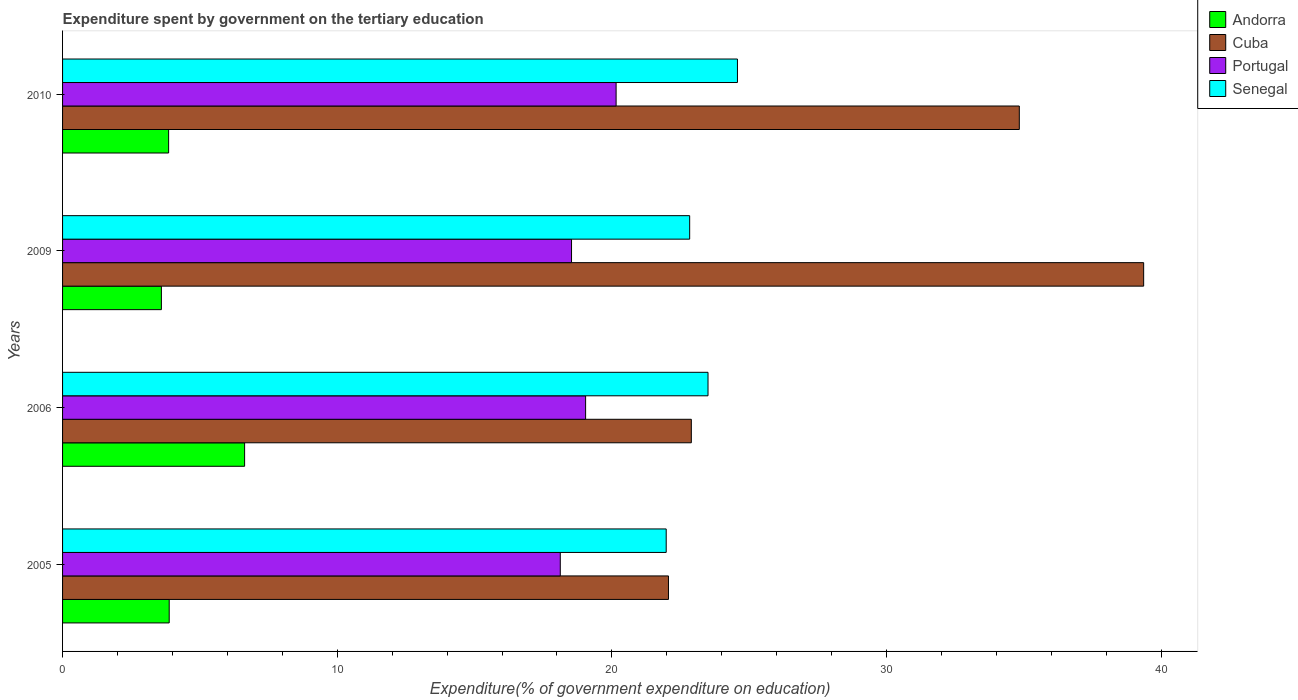Are the number of bars per tick equal to the number of legend labels?
Your answer should be very brief. Yes. How many bars are there on the 2nd tick from the top?
Your answer should be compact. 4. What is the label of the 1st group of bars from the top?
Provide a short and direct response. 2010. In how many cases, is the number of bars for a given year not equal to the number of legend labels?
Your answer should be very brief. 0. What is the expenditure spent by government on the tertiary education in Cuba in 2010?
Offer a terse response. 34.83. Across all years, what is the maximum expenditure spent by government on the tertiary education in Senegal?
Your answer should be very brief. 24.57. Across all years, what is the minimum expenditure spent by government on the tertiary education in Senegal?
Your response must be concise. 21.98. In which year was the expenditure spent by government on the tertiary education in Senegal minimum?
Offer a terse response. 2005. What is the total expenditure spent by government on the tertiary education in Andorra in the graph?
Make the answer very short. 17.97. What is the difference between the expenditure spent by government on the tertiary education in Senegal in 2005 and that in 2006?
Provide a succinct answer. -1.52. What is the difference between the expenditure spent by government on the tertiary education in Portugal in 2010 and the expenditure spent by government on the tertiary education in Cuba in 2009?
Your answer should be compact. -19.21. What is the average expenditure spent by government on the tertiary education in Andorra per year?
Your response must be concise. 4.49. In the year 2009, what is the difference between the expenditure spent by government on the tertiary education in Portugal and expenditure spent by government on the tertiary education in Senegal?
Offer a very short reply. -4.3. In how many years, is the expenditure spent by government on the tertiary education in Senegal greater than 8 %?
Your answer should be compact. 4. What is the ratio of the expenditure spent by government on the tertiary education in Portugal in 2005 to that in 2010?
Provide a succinct answer. 0.9. Is the expenditure spent by government on the tertiary education in Senegal in 2005 less than that in 2006?
Make the answer very short. Yes. Is the difference between the expenditure spent by government on the tertiary education in Portugal in 2009 and 2010 greater than the difference between the expenditure spent by government on the tertiary education in Senegal in 2009 and 2010?
Ensure brevity in your answer.  Yes. What is the difference between the highest and the second highest expenditure spent by government on the tertiary education in Portugal?
Keep it short and to the point. 1.11. What is the difference between the highest and the lowest expenditure spent by government on the tertiary education in Cuba?
Your answer should be compact. 17.3. What does the 1st bar from the top in 2005 represents?
Give a very brief answer. Senegal. What does the 2nd bar from the bottom in 2006 represents?
Provide a short and direct response. Cuba. Is it the case that in every year, the sum of the expenditure spent by government on the tertiary education in Senegal and expenditure spent by government on the tertiary education in Cuba is greater than the expenditure spent by government on the tertiary education in Portugal?
Provide a short and direct response. Yes. How many bars are there?
Provide a succinct answer. 16. Are all the bars in the graph horizontal?
Offer a very short reply. Yes. How many years are there in the graph?
Keep it short and to the point. 4. Does the graph contain any zero values?
Your response must be concise. No. Does the graph contain grids?
Make the answer very short. No. How many legend labels are there?
Ensure brevity in your answer.  4. How are the legend labels stacked?
Offer a very short reply. Vertical. What is the title of the graph?
Your answer should be very brief. Expenditure spent by government on the tertiary education. What is the label or title of the X-axis?
Offer a very short reply. Expenditure(% of government expenditure on education). What is the Expenditure(% of government expenditure on education) in Andorra in 2005?
Ensure brevity in your answer.  3.88. What is the Expenditure(% of government expenditure on education) of Cuba in 2005?
Your answer should be compact. 22.06. What is the Expenditure(% of government expenditure on education) in Portugal in 2005?
Your response must be concise. 18.12. What is the Expenditure(% of government expenditure on education) of Senegal in 2005?
Your response must be concise. 21.98. What is the Expenditure(% of government expenditure on education) in Andorra in 2006?
Ensure brevity in your answer.  6.63. What is the Expenditure(% of government expenditure on education) in Cuba in 2006?
Your answer should be very brief. 22.89. What is the Expenditure(% of government expenditure on education) of Portugal in 2006?
Your answer should be very brief. 19.04. What is the Expenditure(% of government expenditure on education) in Senegal in 2006?
Give a very brief answer. 23.5. What is the Expenditure(% of government expenditure on education) in Andorra in 2009?
Ensure brevity in your answer.  3.6. What is the Expenditure(% of government expenditure on education) in Cuba in 2009?
Keep it short and to the point. 39.36. What is the Expenditure(% of government expenditure on education) in Portugal in 2009?
Provide a short and direct response. 18.53. What is the Expenditure(% of government expenditure on education) of Senegal in 2009?
Your answer should be compact. 22.83. What is the Expenditure(% of government expenditure on education) of Andorra in 2010?
Your response must be concise. 3.86. What is the Expenditure(% of government expenditure on education) of Cuba in 2010?
Make the answer very short. 34.83. What is the Expenditure(% of government expenditure on education) in Portugal in 2010?
Offer a terse response. 20.15. What is the Expenditure(% of government expenditure on education) in Senegal in 2010?
Offer a very short reply. 24.57. Across all years, what is the maximum Expenditure(% of government expenditure on education) of Andorra?
Provide a short and direct response. 6.63. Across all years, what is the maximum Expenditure(% of government expenditure on education) of Cuba?
Your response must be concise. 39.36. Across all years, what is the maximum Expenditure(% of government expenditure on education) of Portugal?
Provide a succinct answer. 20.15. Across all years, what is the maximum Expenditure(% of government expenditure on education) in Senegal?
Ensure brevity in your answer.  24.57. Across all years, what is the minimum Expenditure(% of government expenditure on education) in Andorra?
Your answer should be very brief. 3.6. Across all years, what is the minimum Expenditure(% of government expenditure on education) of Cuba?
Your answer should be very brief. 22.06. Across all years, what is the minimum Expenditure(% of government expenditure on education) of Portugal?
Your response must be concise. 18.12. Across all years, what is the minimum Expenditure(% of government expenditure on education) in Senegal?
Keep it short and to the point. 21.98. What is the total Expenditure(% of government expenditure on education) of Andorra in the graph?
Offer a very short reply. 17.97. What is the total Expenditure(% of government expenditure on education) of Cuba in the graph?
Offer a very short reply. 119.15. What is the total Expenditure(% of government expenditure on education) of Portugal in the graph?
Ensure brevity in your answer.  75.85. What is the total Expenditure(% of government expenditure on education) of Senegal in the graph?
Ensure brevity in your answer.  92.88. What is the difference between the Expenditure(% of government expenditure on education) in Andorra in 2005 and that in 2006?
Give a very brief answer. -2.75. What is the difference between the Expenditure(% of government expenditure on education) of Cuba in 2005 and that in 2006?
Provide a succinct answer. -0.83. What is the difference between the Expenditure(% of government expenditure on education) in Portugal in 2005 and that in 2006?
Offer a very short reply. -0.92. What is the difference between the Expenditure(% of government expenditure on education) in Senegal in 2005 and that in 2006?
Give a very brief answer. -1.52. What is the difference between the Expenditure(% of government expenditure on education) in Andorra in 2005 and that in 2009?
Make the answer very short. 0.28. What is the difference between the Expenditure(% of government expenditure on education) of Cuba in 2005 and that in 2009?
Make the answer very short. -17.3. What is the difference between the Expenditure(% of government expenditure on education) of Portugal in 2005 and that in 2009?
Your answer should be compact. -0.41. What is the difference between the Expenditure(% of government expenditure on education) of Senegal in 2005 and that in 2009?
Offer a terse response. -0.85. What is the difference between the Expenditure(% of government expenditure on education) of Andorra in 2005 and that in 2010?
Your response must be concise. 0.02. What is the difference between the Expenditure(% of government expenditure on education) of Cuba in 2005 and that in 2010?
Provide a short and direct response. -12.77. What is the difference between the Expenditure(% of government expenditure on education) in Portugal in 2005 and that in 2010?
Ensure brevity in your answer.  -2.03. What is the difference between the Expenditure(% of government expenditure on education) of Senegal in 2005 and that in 2010?
Your answer should be compact. -2.59. What is the difference between the Expenditure(% of government expenditure on education) in Andorra in 2006 and that in 2009?
Offer a very short reply. 3.03. What is the difference between the Expenditure(% of government expenditure on education) of Cuba in 2006 and that in 2009?
Your response must be concise. -16.47. What is the difference between the Expenditure(% of government expenditure on education) in Portugal in 2006 and that in 2009?
Offer a very short reply. 0.51. What is the difference between the Expenditure(% of government expenditure on education) in Senegal in 2006 and that in 2009?
Provide a succinct answer. 0.67. What is the difference between the Expenditure(% of government expenditure on education) of Andorra in 2006 and that in 2010?
Keep it short and to the point. 2.77. What is the difference between the Expenditure(% of government expenditure on education) in Cuba in 2006 and that in 2010?
Your answer should be compact. -11.94. What is the difference between the Expenditure(% of government expenditure on education) of Portugal in 2006 and that in 2010?
Offer a terse response. -1.11. What is the difference between the Expenditure(% of government expenditure on education) of Senegal in 2006 and that in 2010?
Provide a succinct answer. -1.07. What is the difference between the Expenditure(% of government expenditure on education) in Andorra in 2009 and that in 2010?
Keep it short and to the point. -0.26. What is the difference between the Expenditure(% of government expenditure on education) of Cuba in 2009 and that in 2010?
Offer a terse response. 4.53. What is the difference between the Expenditure(% of government expenditure on education) in Portugal in 2009 and that in 2010?
Keep it short and to the point. -1.62. What is the difference between the Expenditure(% of government expenditure on education) in Senegal in 2009 and that in 2010?
Provide a succinct answer. -1.74. What is the difference between the Expenditure(% of government expenditure on education) in Andorra in 2005 and the Expenditure(% of government expenditure on education) in Cuba in 2006?
Provide a short and direct response. -19.01. What is the difference between the Expenditure(% of government expenditure on education) of Andorra in 2005 and the Expenditure(% of government expenditure on education) of Portugal in 2006?
Your answer should be very brief. -15.16. What is the difference between the Expenditure(% of government expenditure on education) of Andorra in 2005 and the Expenditure(% of government expenditure on education) of Senegal in 2006?
Offer a very short reply. -19.62. What is the difference between the Expenditure(% of government expenditure on education) of Cuba in 2005 and the Expenditure(% of government expenditure on education) of Portugal in 2006?
Make the answer very short. 3.02. What is the difference between the Expenditure(% of government expenditure on education) of Cuba in 2005 and the Expenditure(% of government expenditure on education) of Senegal in 2006?
Make the answer very short. -1.44. What is the difference between the Expenditure(% of government expenditure on education) of Portugal in 2005 and the Expenditure(% of government expenditure on education) of Senegal in 2006?
Your answer should be very brief. -5.38. What is the difference between the Expenditure(% of government expenditure on education) of Andorra in 2005 and the Expenditure(% of government expenditure on education) of Cuba in 2009?
Offer a terse response. -35.48. What is the difference between the Expenditure(% of government expenditure on education) in Andorra in 2005 and the Expenditure(% of government expenditure on education) in Portugal in 2009?
Offer a very short reply. -14.65. What is the difference between the Expenditure(% of government expenditure on education) in Andorra in 2005 and the Expenditure(% of government expenditure on education) in Senegal in 2009?
Provide a succinct answer. -18.95. What is the difference between the Expenditure(% of government expenditure on education) of Cuba in 2005 and the Expenditure(% of government expenditure on education) of Portugal in 2009?
Your answer should be very brief. 3.53. What is the difference between the Expenditure(% of government expenditure on education) of Cuba in 2005 and the Expenditure(% of government expenditure on education) of Senegal in 2009?
Ensure brevity in your answer.  -0.77. What is the difference between the Expenditure(% of government expenditure on education) in Portugal in 2005 and the Expenditure(% of government expenditure on education) in Senegal in 2009?
Provide a succinct answer. -4.71. What is the difference between the Expenditure(% of government expenditure on education) of Andorra in 2005 and the Expenditure(% of government expenditure on education) of Cuba in 2010?
Your answer should be very brief. -30.95. What is the difference between the Expenditure(% of government expenditure on education) of Andorra in 2005 and the Expenditure(% of government expenditure on education) of Portugal in 2010?
Provide a succinct answer. -16.27. What is the difference between the Expenditure(% of government expenditure on education) of Andorra in 2005 and the Expenditure(% of government expenditure on education) of Senegal in 2010?
Your answer should be compact. -20.69. What is the difference between the Expenditure(% of government expenditure on education) of Cuba in 2005 and the Expenditure(% of government expenditure on education) of Portugal in 2010?
Keep it short and to the point. 1.91. What is the difference between the Expenditure(% of government expenditure on education) in Cuba in 2005 and the Expenditure(% of government expenditure on education) in Senegal in 2010?
Provide a short and direct response. -2.51. What is the difference between the Expenditure(% of government expenditure on education) of Portugal in 2005 and the Expenditure(% of government expenditure on education) of Senegal in 2010?
Give a very brief answer. -6.45. What is the difference between the Expenditure(% of government expenditure on education) of Andorra in 2006 and the Expenditure(% of government expenditure on education) of Cuba in 2009?
Your answer should be very brief. -32.73. What is the difference between the Expenditure(% of government expenditure on education) of Andorra in 2006 and the Expenditure(% of government expenditure on education) of Portugal in 2009?
Provide a short and direct response. -11.9. What is the difference between the Expenditure(% of government expenditure on education) in Andorra in 2006 and the Expenditure(% of government expenditure on education) in Senegal in 2009?
Provide a short and direct response. -16.2. What is the difference between the Expenditure(% of government expenditure on education) in Cuba in 2006 and the Expenditure(% of government expenditure on education) in Portugal in 2009?
Your response must be concise. 4.36. What is the difference between the Expenditure(% of government expenditure on education) in Cuba in 2006 and the Expenditure(% of government expenditure on education) in Senegal in 2009?
Your answer should be very brief. 0.06. What is the difference between the Expenditure(% of government expenditure on education) of Portugal in 2006 and the Expenditure(% of government expenditure on education) of Senegal in 2009?
Your response must be concise. -3.79. What is the difference between the Expenditure(% of government expenditure on education) in Andorra in 2006 and the Expenditure(% of government expenditure on education) in Cuba in 2010?
Make the answer very short. -28.21. What is the difference between the Expenditure(% of government expenditure on education) of Andorra in 2006 and the Expenditure(% of government expenditure on education) of Portugal in 2010?
Make the answer very short. -13.53. What is the difference between the Expenditure(% of government expenditure on education) in Andorra in 2006 and the Expenditure(% of government expenditure on education) in Senegal in 2010?
Keep it short and to the point. -17.94. What is the difference between the Expenditure(% of government expenditure on education) of Cuba in 2006 and the Expenditure(% of government expenditure on education) of Portugal in 2010?
Provide a succinct answer. 2.74. What is the difference between the Expenditure(% of government expenditure on education) in Cuba in 2006 and the Expenditure(% of government expenditure on education) in Senegal in 2010?
Provide a short and direct response. -1.68. What is the difference between the Expenditure(% of government expenditure on education) in Portugal in 2006 and the Expenditure(% of government expenditure on education) in Senegal in 2010?
Keep it short and to the point. -5.53. What is the difference between the Expenditure(% of government expenditure on education) of Andorra in 2009 and the Expenditure(% of government expenditure on education) of Cuba in 2010?
Offer a very short reply. -31.24. What is the difference between the Expenditure(% of government expenditure on education) in Andorra in 2009 and the Expenditure(% of government expenditure on education) in Portugal in 2010?
Give a very brief answer. -16.56. What is the difference between the Expenditure(% of government expenditure on education) of Andorra in 2009 and the Expenditure(% of government expenditure on education) of Senegal in 2010?
Your answer should be very brief. -20.97. What is the difference between the Expenditure(% of government expenditure on education) in Cuba in 2009 and the Expenditure(% of government expenditure on education) in Portugal in 2010?
Your response must be concise. 19.21. What is the difference between the Expenditure(% of government expenditure on education) in Cuba in 2009 and the Expenditure(% of government expenditure on education) in Senegal in 2010?
Your response must be concise. 14.79. What is the difference between the Expenditure(% of government expenditure on education) in Portugal in 2009 and the Expenditure(% of government expenditure on education) in Senegal in 2010?
Make the answer very short. -6.04. What is the average Expenditure(% of government expenditure on education) of Andorra per year?
Your response must be concise. 4.49. What is the average Expenditure(% of government expenditure on education) in Cuba per year?
Ensure brevity in your answer.  29.79. What is the average Expenditure(% of government expenditure on education) of Portugal per year?
Your answer should be very brief. 18.96. What is the average Expenditure(% of government expenditure on education) in Senegal per year?
Keep it short and to the point. 23.22. In the year 2005, what is the difference between the Expenditure(% of government expenditure on education) in Andorra and Expenditure(% of government expenditure on education) in Cuba?
Offer a terse response. -18.18. In the year 2005, what is the difference between the Expenditure(% of government expenditure on education) of Andorra and Expenditure(% of government expenditure on education) of Portugal?
Offer a very short reply. -14.24. In the year 2005, what is the difference between the Expenditure(% of government expenditure on education) in Andorra and Expenditure(% of government expenditure on education) in Senegal?
Offer a very short reply. -18.1. In the year 2005, what is the difference between the Expenditure(% of government expenditure on education) of Cuba and Expenditure(% of government expenditure on education) of Portugal?
Offer a terse response. 3.94. In the year 2005, what is the difference between the Expenditure(% of government expenditure on education) in Cuba and Expenditure(% of government expenditure on education) in Senegal?
Provide a short and direct response. 0.08. In the year 2005, what is the difference between the Expenditure(% of government expenditure on education) in Portugal and Expenditure(% of government expenditure on education) in Senegal?
Your response must be concise. -3.86. In the year 2006, what is the difference between the Expenditure(% of government expenditure on education) in Andorra and Expenditure(% of government expenditure on education) in Cuba?
Offer a terse response. -16.27. In the year 2006, what is the difference between the Expenditure(% of government expenditure on education) of Andorra and Expenditure(% of government expenditure on education) of Portugal?
Make the answer very short. -12.42. In the year 2006, what is the difference between the Expenditure(% of government expenditure on education) of Andorra and Expenditure(% of government expenditure on education) of Senegal?
Keep it short and to the point. -16.87. In the year 2006, what is the difference between the Expenditure(% of government expenditure on education) in Cuba and Expenditure(% of government expenditure on education) in Portugal?
Offer a very short reply. 3.85. In the year 2006, what is the difference between the Expenditure(% of government expenditure on education) in Cuba and Expenditure(% of government expenditure on education) in Senegal?
Keep it short and to the point. -0.61. In the year 2006, what is the difference between the Expenditure(% of government expenditure on education) in Portugal and Expenditure(% of government expenditure on education) in Senegal?
Your response must be concise. -4.46. In the year 2009, what is the difference between the Expenditure(% of government expenditure on education) in Andorra and Expenditure(% of government expenditure on education) in Cuba?
Your answer should be very brief. -35.76. In the year 2009, what is the difference between the Expenditure(% of government expenditure on education) of Andorra and Expenditure(% of government expenditure on education) of Portugal?
Make the answer very short. -14.93. In the year 2009, what is the difference between the Expenditure(% of government expenditure on education) in Andorra and Expenditure(% of government expenditure on education) in Senegal?
Your answer should be compact. -19.23. In the year 2009, what is the difference between the Expenditure(% of government expenditure on education) in Cuba and Expenditure(% of government expenditure on education) in Portugal?
Provide a short and direct response. 20.83. In the year 2009, what is the difference between the Expenditure(% of government expenditure on education) of Cuba and Expenditure(% of government expenditure on education) of Senegal?
Your answer should be compact. 16.53. In the year 2009, what is the difference between the Expenditure(% of government expenditure on education) of Portugal and Expenditure(% of government expenditure on education) of Senegal?
Your response must be concise. -4.3. In the year 2010, what is the difference between the Expenditure(% of government expenditure on education) in Andorra and Expenditure(% of government expenditure on education) in Cuba?
Your response must be concise. -30.97. In the year 2010, what is the difference between the Expenditure(% of government expenditure on education) in Andorra and Expenditure(% of government expenditure on education) in Portugal?
Your answer should be compact. -16.29. In the year 2010, what is the difference between the Expenditure(% of government expenditure on education) in Andorra and Expenditure(% of government expenditure on education) in Senegal?
Your answer should be very brief. -20.71. In the year 2010, what is the difference between the Expenditure(% of government expenditure on education) of Cuba and Expenditure(% of government expenditure on education) of Portugal?
Offer a terse response. 14.68. In the year 2010, what is the difference between the Expenditure(% of government expenditure on education) of Cuba and Expenditure(% of government expenditure on education) of Senegal?
Provide a succinct answer. 10.26. In the year 2010, what is the difference between the Expenditure(% of government expenditure on education) of Portugal and Expenditure(% of government expenditure on education) of Senegal?
Offer a very short reply. -4.42. What is the ratio of the Expenditure(% of government expenditure on education) of Andorra in 2005 to that in 2006?
Your response must be concise. 0.59. What is the ratio of the Expenditure(% of government expenditure on education) in Cuba in 2005 to that in 2006?
Provide a short and direct response. 0.96. What is the ratio of the Expenditure(% of government expenditure on education) in Portugal in 2005 to that in 2006?
Your response must be concise. 0.95. What is the ratio of the Expenditure(% of government expenditure on education) in Senegal in 2005 to that in 2006?
Your answer should be very brief. 0.94. What is the ratio of the Expenditure(% of government expenditure on education) of Andorra in 2005 to that in 2009?
Your answer should be compact. 1.08. What is the ratio of the Expenditure(% of government expenditure on education) of Cuba in 2005 to that in 2009?
Give a very brief answer. 0.56. What is the ratio of the Expenditure(% of government expenditure on education) of Portugal in 2005 to that in 2009?
Ensure brevity in your answer.  0.98. What is the ratio of the Expenditure(% of government expenditure on education) in Senegal in 2005 to that in 2009?
Your response must be concise. 0.96. What is the ratio of the Expenditure(% of government expenditure on education) of Andorra in 2005 to that in 2010?
Offer a terse response. 1.01. What is the ratio of the Expenditure(% of government expenditure on education) in Cuba in 2005 to that in 2010?
Offer a very short reply. 0.63. What is the ratio of the Expenditure(% of government expenditure on education) of Portugal in 2005 to that in 2010?
Give a very brief answer. 0.9. What is the ratio of the Expenditure(% of government expenditure on education) of Senegal in 2005 to that in 2010?
Ensure brevity in your answer.  0.89. What is the ratio of the Expenditure(% of government expenditure on education) of Andorra in 2006 to that in 2009?
Your answer should be very brief. 1.84. What is the ratio of the Expenditure(% of government expenditure on education) in Cuba in 2006 to that in 2009?
Offer a terse response. 0.58. What is the ratio of the Expenditure(% of government expenditure on education) in Portugal in 2006 to that in 2009?
Keep it short and to the point. 1.03. What is the ratio of the Expenditure(% of government expenditure on education) of Senegal in 2006 to that in 2009?
Your response must be concise. 1.03. What is the ratio of the Expenditure(% of government expenditure on education) in Andorra in 2006 to that in 2010?
Offer a terse response. 1.72. What is the ratio of the Expenditure(% of government expenditure on education) in Cuba in 2006 to that in 2010?
Your answer should be very brief. 0.66. What is the ratio of the Expenditure(% of government expenditure on education) of Portugal in 2006 to that in 2010?
Your response must be concise. 0.94. What is the ratio of the Expenditure(% of government expenditure on education) in Senegal in 2006 to that in 2010?
Your response must be concise. 0.96. What is the ratio of the Expenditure(% of government expenditure on education) in Andorra in 2009 to that in 2010?
Your answer should be very brief. 0.93. What is the ratio of the Expenditure(% of government expenditure on education) in Cuba in 2009 to that in 2010?
Make the answer very short. 1.13. What is the ratio of the Expenditure(% of government expenditure on education) of Portugal in 2009 to that in 2010?
Your response must be concise. 0.92. What is the ratio of the Expenditure(% of government expenditure on education) in Senegal in 2009 to that in 2010?
Keep it short and to the point. 0.93. What is the difference between the highest and the second highest Expenditure(% of government expenditure on education) in Andorra?
Keep it short and to the point. 2.75. What is the difference between the highest and the second highest Expenditure(% of government expenditure on education) of Cuba?
Your answer should be very brief. 4.53. What is the difference between the highest and the second highest Expenditure(% of government expenditure on education) in Portugal?
Ensure brevity in your answer.  1.11. What is the difference between the highest and the second highest Expenditure(% of government expenditure on education) of Senegal?
Keep it short and to the point. 1.07. What is the difference between the highest and the lowest Expenditure(% of government expenditure on education) in Andorra?
Provide a succinct answer. 3.03. What is the difference between the highest and the lowest Expenditure(% of government expenditure on education) of Cuba?
Your response must be concise. 17.3. What is the difference between the highest and the lowest Expenditure(% of government expenditure on education) of Portugal?
Your answer should be very brief. 2.03. What is the difference between the highest and the lowest Expenditure(% of government expenditure on education) of Senegal?
Your response must be concise. 2.59. 